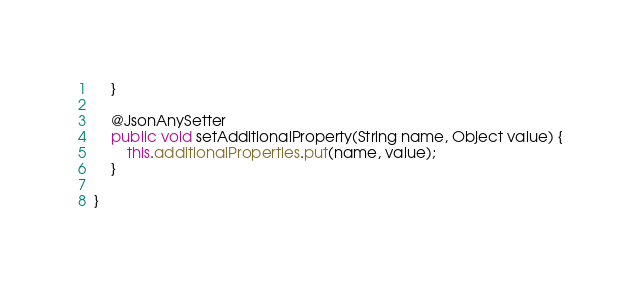<code> <loc_0><loc_0><loc_500><loc_500><_Java_>    }

    @JsonAnySetter
    public void setAdditionalProperty(String name, Object value) {
        this.additionalProperties.put(name, value);
    }

}
</code> 